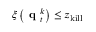Convert formula to latex. <formula><loc_0><loc_0><loc_500><loc_500>\xi \left ( { q } _ { t } ^ { k } \right ) \leq z _ { k i l l }</formula> 